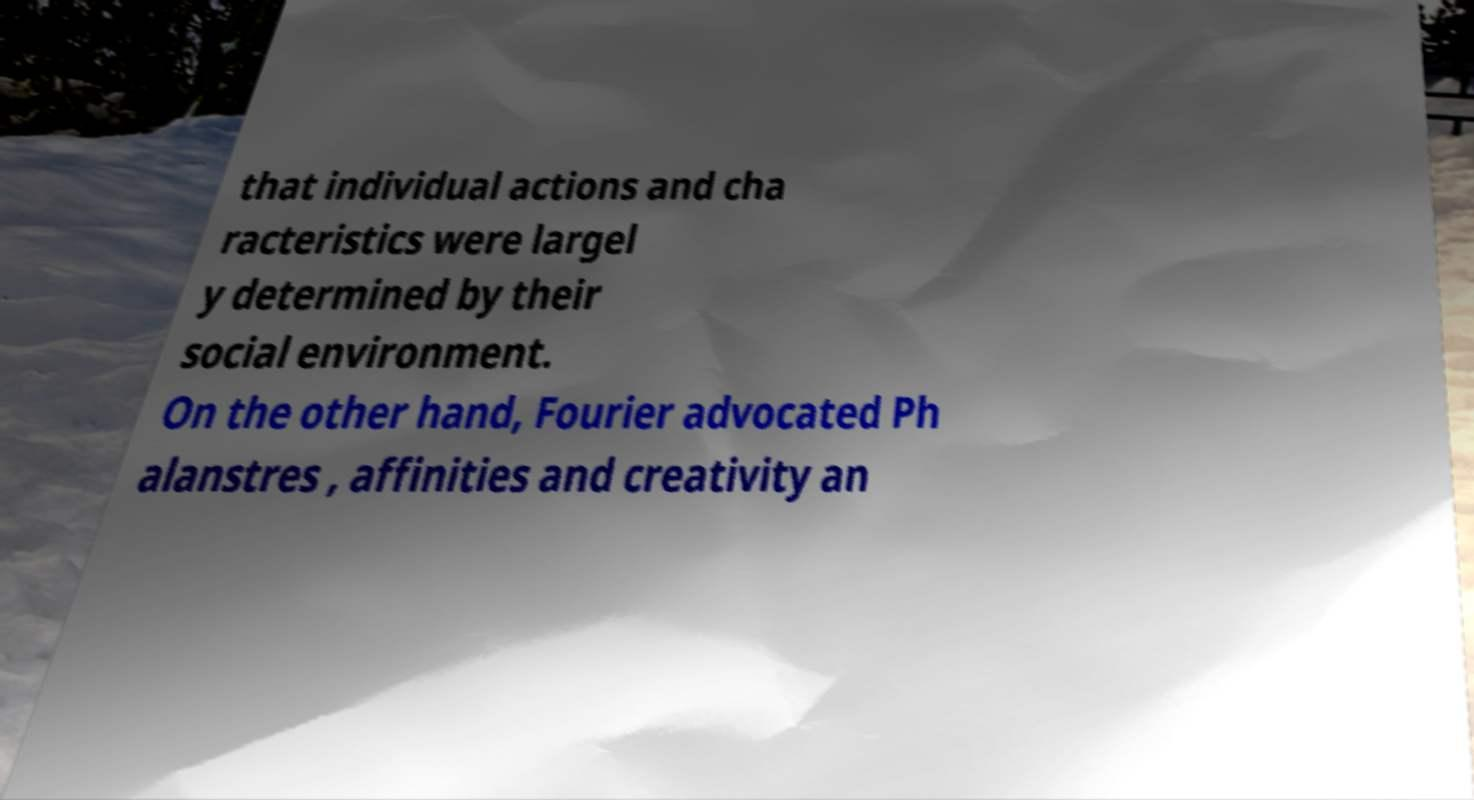Can you accurately transcribe the text from the provided image for me? that individual actions and cha racteristics were largel y determined by their social environment. On the other hand, Fourier advocated Ph alanstres , affinities and creativity an 